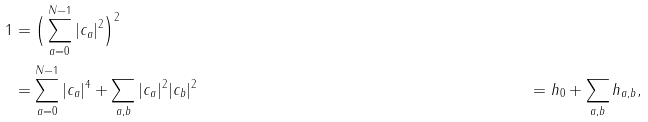<formula> <loc_0><loc_0><loc_500><loc_500>1 & = \Big { ( } \sum _ { a = 0 } ^ { N - 1 } | c _ { a } | ^ { 2 } \Big { ) } ^ { 2 } \\ & = \sum _ { a = 0 } ^ { N - 1 } | c _ { a } | ^ { 4 } + \sum _ { a , b } | c _ { a } | ^ { 2 } | c _ { b } | ^ { 2 } & = h _ { 0 } + \sum _ { a , b } h _ { a , b } ,</formula> 